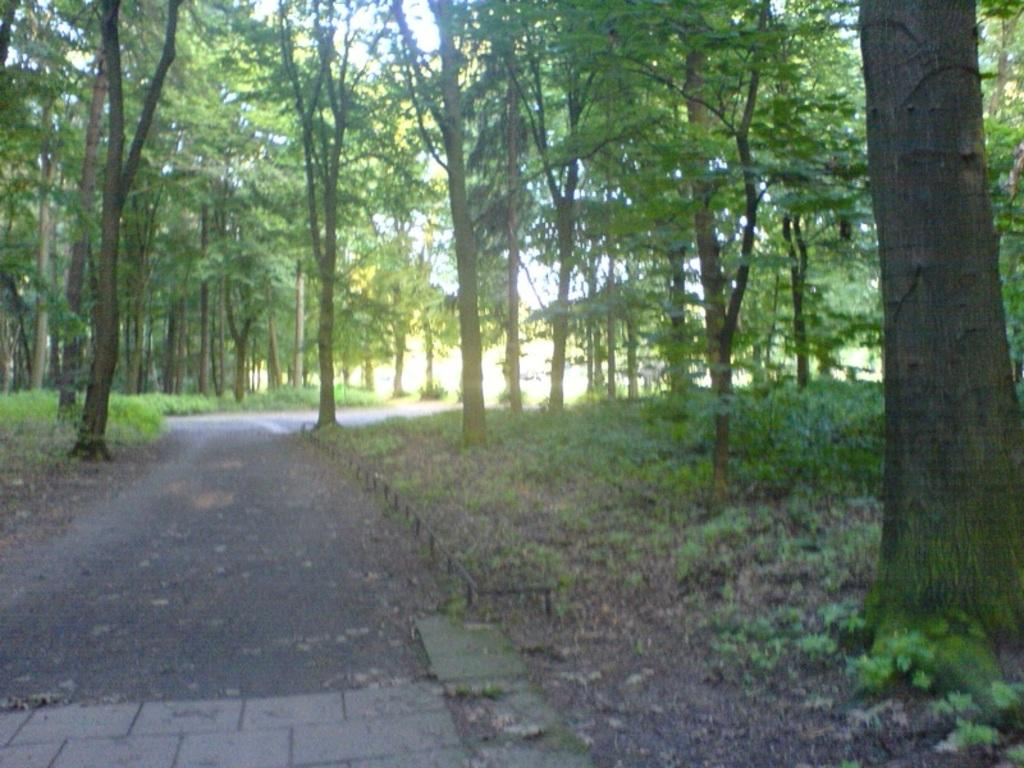What is the main feature of the image? There is a road in the image. What else can be seen alongside the road? There are trees in the image. What type of vegetation is present in the image? There are plants in the image, and they are green in color. What can be seen in the background of the image? The sky is visible in the background of the image. Where is the friend holding the locket in the image? There is no friend or locket present in the image; it only features a road, trees, plants, and the sky. 